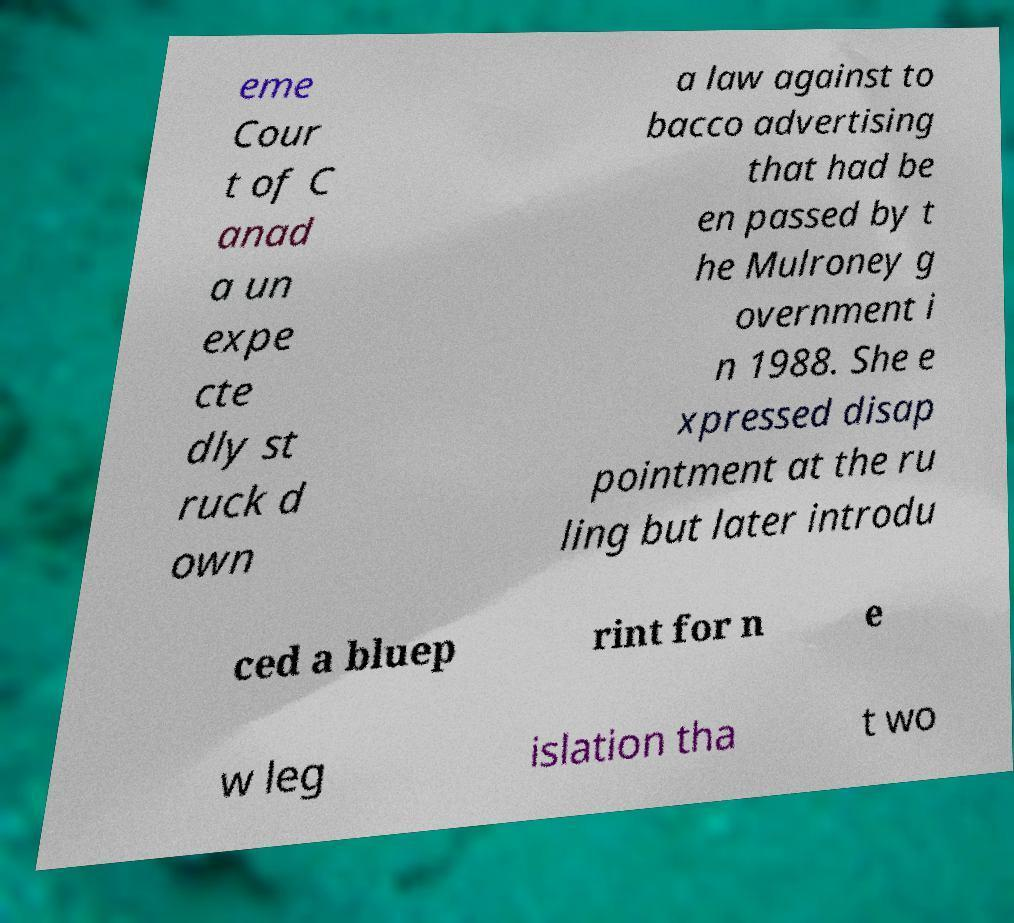Please read and relay the text visible in this image. What does it say? eme Cour t of C anad a un expe cte dly st ruck d own a law against to bacco advertising that had be en passed by t he Mulroney g overnment i n 1988. She e xpressed disap pointment at the ru ling but later introdu ced a bluep rint for n e w leg islation tha t wo 